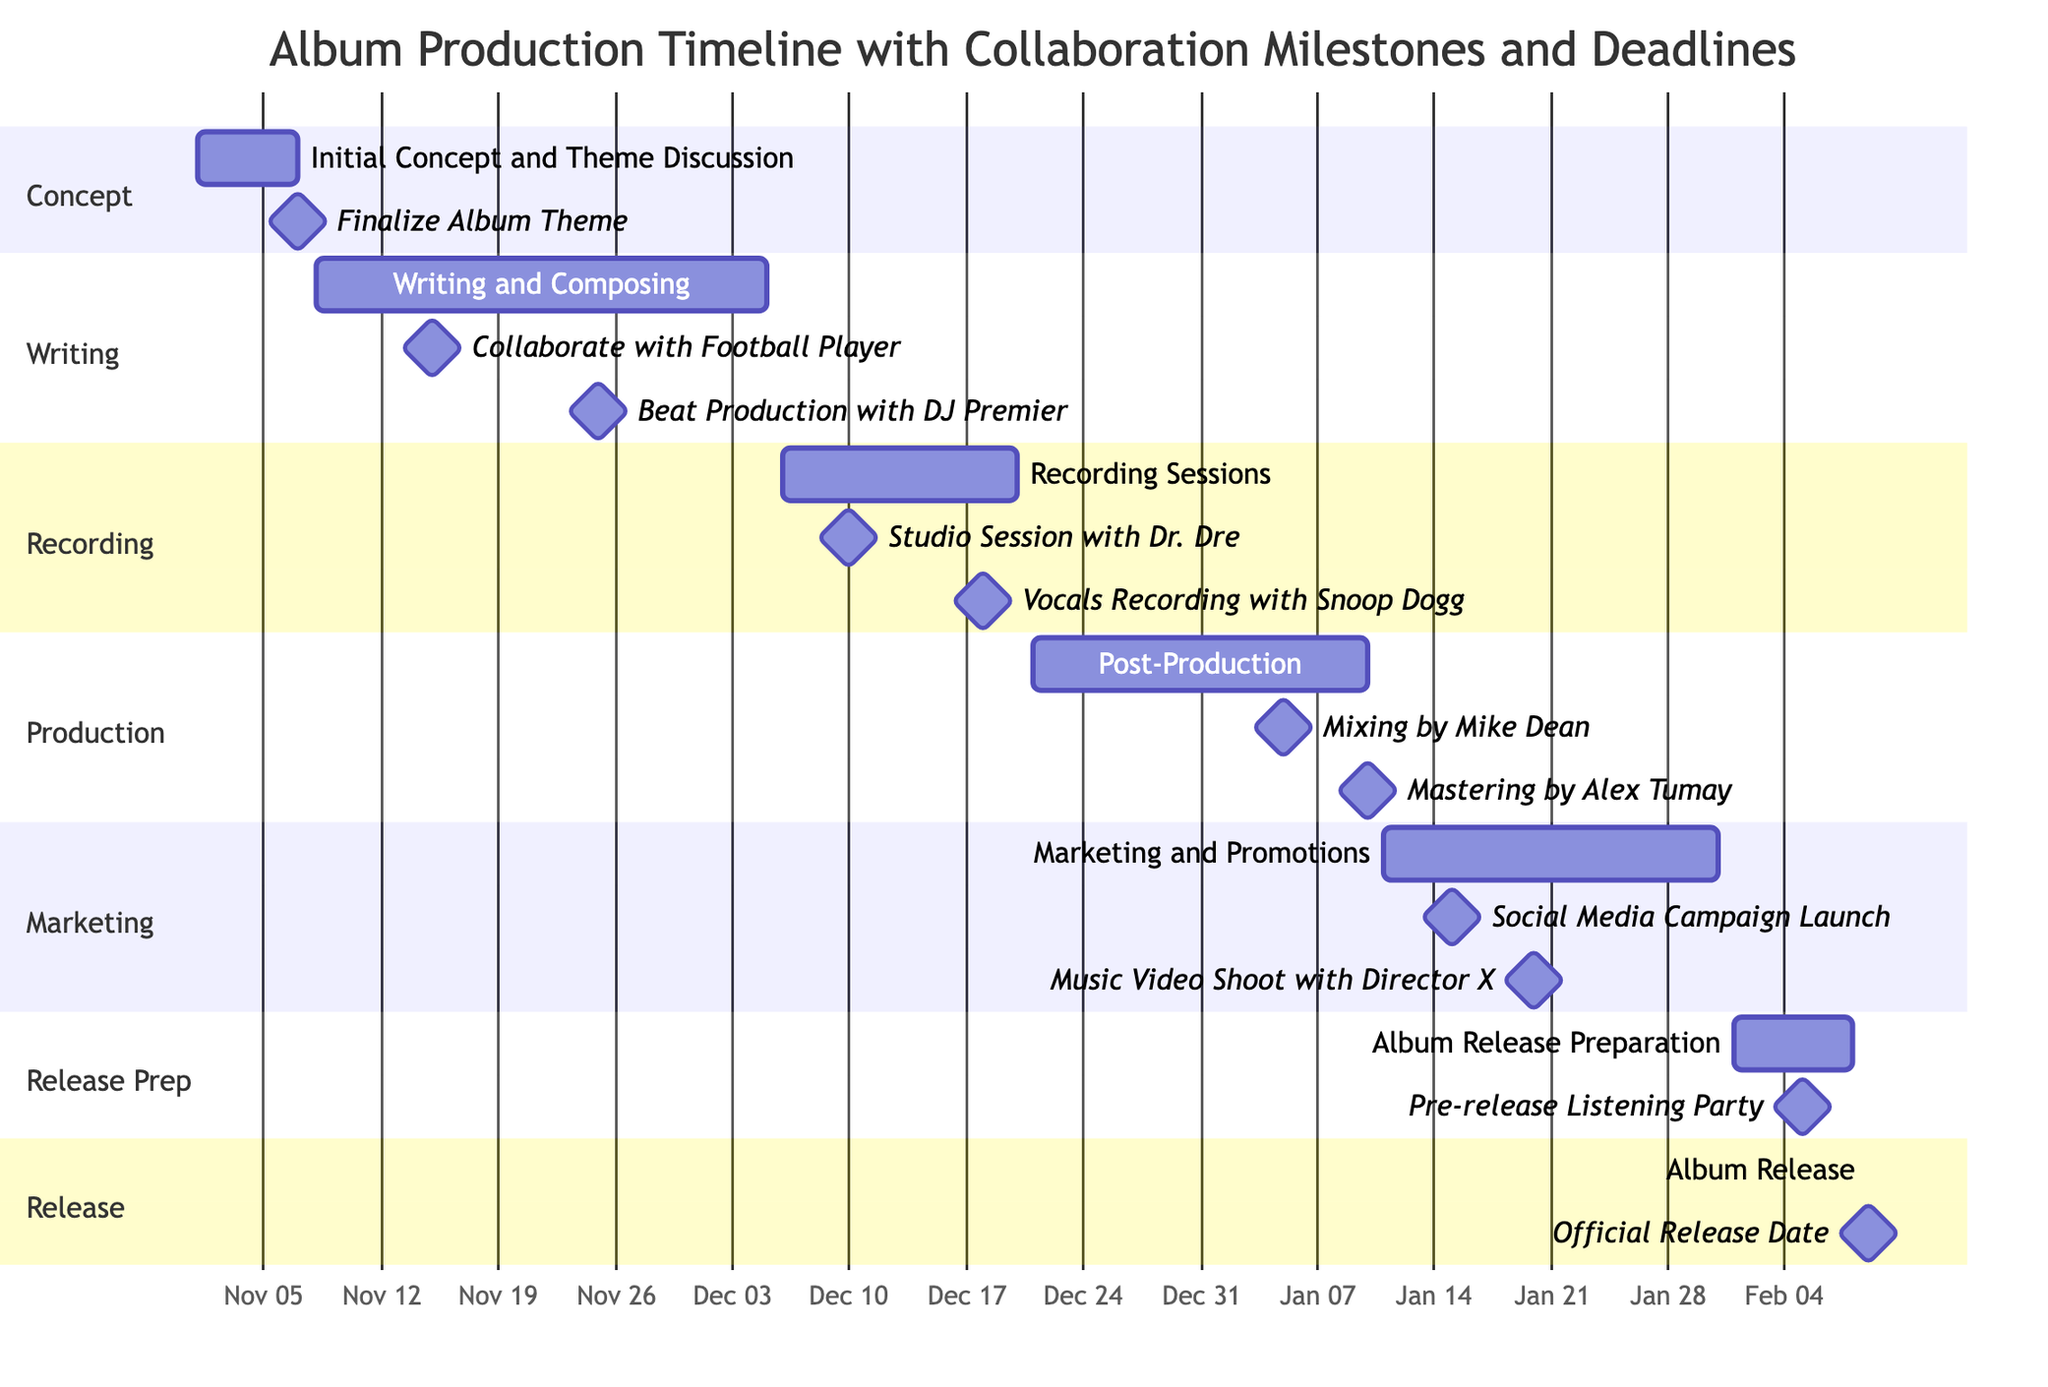What is the start date for the Writing and Composing task? The diagram shows that the Writing and Composing task starts on November 8, 2023, as stated in the timeline section.
Answer: November 8, 2023 How many milestones are set for the recording sessions? In the Recording Sessions task, there are two milestones listed: one with Dr. Dre and one with Snoop Dogg. Thus, the total number of milestones is two.
Answer: 2 What is the end date for the marketing and promotions phase? The timeline specifies that the Marketing and Promotions task ends on January 31, 2024, thus the end date for this phase is clearly stated.
Answer: January 31, 2024 Which task includes a milestone with DJ Premier? Reviewing the diagram, the Beat Production milestone is mentioned under the Writing and Composing task, which indicates that this specific task includes a milestone with DJ Premier.
Answer: Writing and Composing What is the official release date of the album? The diagram states that the Album Release task has an official release date on February 9, 2024, as indicated in the timeline.
Answer: February 9, 2024 Which task overlaps with the completion of the writing phase? The diagram indicates that the Recording Sessions task, which begins on December 6, 2023, overlaps with the end of the Writing and Composing phase on December 5, 2023.
Answer: Recording Sessions What is the date for the Pre-release Listening Party milestone? According to the timeline, the Pre-release Listening Party milestone is set for February 5, 2024, listed under the Album Release Preparation task.
Answer: February 5, 2024 Who is involved in the mixing milestone of the post-production phase? The milestone for mixing is assigned to Mike Dean, as specified in the Post-Production section of the diagram.
Answer: Mike Dean In which section is the Social Media Campaign Launch milestone located? The Social Media Campaign Launch milestone is located in the Marketing section, as represented in the timeline.
Answer: Marketing 